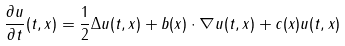Convert formula to latex. <formula><loc_0><loc_0><loc_500><loc_500>\frac { \partial u } { \partial t } ( t , x ) = \frac { 1 } { 2 } \Delta u ( t , x ) + b ( x ) \cdot \nabla u ( t , x ) + c ( x ) u ( t , x )</formula> 